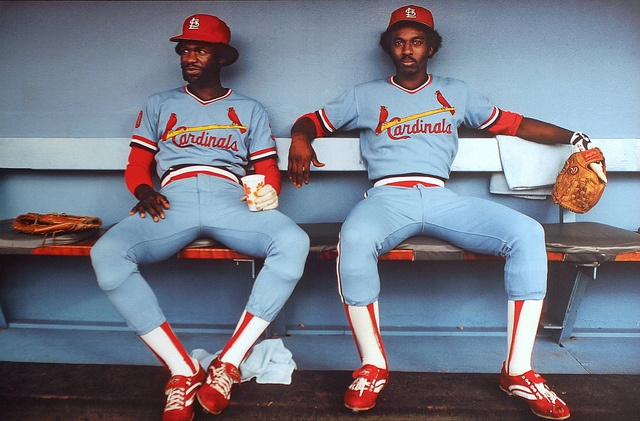Describe the objects in this image and their specific colors. I can see people in black, lightblue, darkgray, and gray tones, people in black, lightblue, white, and maroon tones, bench in black, white, gray, and lightblue tones, baseball glove in black, brown, orange, red, and salmon tones, and baseball glove in black, maroon, and brown tones in this image. 